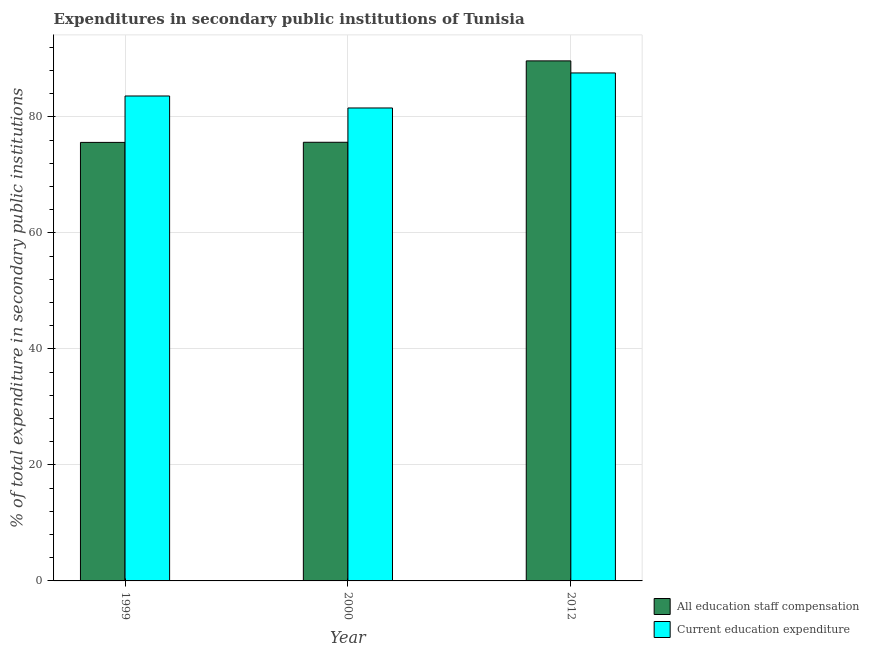How many different coloured bars are there?
Your answer should be compact. 2. Are the number of bars on each tick of the X-axis equal?
Provide a short and direct response. Yes. How many bars are there on the 3rd tick from the left?
Provide a short and direct response. 2. What is the expenditure in staff compensation in 1999?
Make the answer very short. 75.6. Across all years, what is the maximum expenditure in education?
Your answer should be very brief. 87.57. Across all years, what is the minimum expenditure in education?
Your answer should be compact. 81.53. What is the total expenditure in education in the graph?
Keep it short and to the point. 252.71. What is the difference between the expenditure in staff compensation in 1999 and that in 2012?
Provide a short and direct response. -14.05. What is the difference between the expenditure in staff compensation in 2012 and the expenditure in education in 1999?
Keep it short and to the point. 14.05. What is the average expenditure in staff compensation per year?
Provide a short and direct response. 80.29. What is the ratio of the expenditure in staff compensation in 1999 to that in 2012?
Keep it short and to the point. 0.84. Is the expenditure in staff compensation in 1999 less than that in 2012?
Provide a succinct answer. Yes. Is the difference between the expenditure in staff compensation in 2000 and 2012 greater than the difference between the expenditure in education in 2000 and 2012?
Ensure brevity in your answer.  No. What is the difference between the highest and the second highest expenditure in staff compensation?
Keep it short and to the point. 14.03. What is the difference between the highest and the lowest expenditure in education?
Offer a terse response. 6.04. In how many years, is the expenditure in education greater than the average expenditure in education taken over all years?
Make the answer very short. 1. What does the 1st bar from the left in 2000 represents?
Your answer should be compact. All education staff compensation. What does the 1st bar from the right in 2012 represents?
Your answer should be compact. Current education expenditure. How many bars are there?
Offer a terse response. 6. Are all the bars in the graph horizontal?
Give a very brief answer. No. How many years are there in the graph?
Your answer should be very brief. 3. Are the values on the major ticks of Y-axis written in scientific E-notation?
Provide a short and direct response. No. Does the graph contain any zero values?
Your response must be concise. No. Does the graph contain grids?
Your answer should be very brief. Yes. How many legend labels are there?
Provide a succinct answer. 2. How are the legend labels stacked?
Offer a terse response. Vertical. What is the title of the graph?
Your response must be concise. Expenditures in secondary public institutions of Tunisia. Does "Death rate" appear as one of the legend labels in the graph?
Your answer should be compact. No. What is the label or title of the Y-axis?
Offer a terse response. % of total expenditure in secondary public institutions. What is the % of total expenditure in secondary public institutions of All education staff compensation in 1999?
Your answer should be very brief. 75.6. What is the % of total expenditure in secondary public institutions of Current education expenditure in 1999?
Provide a short and direct response. 83.6. What is the % of total expenditure in secondary public institutions in All education staff compensation in 2000?
Your answer should be compact. 75.62. What is the % of total expenditure in secondary public institutions in Current education expenditure in 2000?
Make the answer very short. 81.53. What is the % of total expenditure in secondary public institutions of All education staff compensation in 2012?
Make the answer very short. 89.65. What is the % of total expenditure in secondary public institutions in Current education expenditure in 2012?
Your answer should be very brief. 87.57. Across all years, what is the maximum % of total expenditure in secondary public institutions in All education staff compensation?
Give a very brief answer. 89.65. Across all years, what is the maximum % of total expenditure in secondary public institutions in Current education expenditure?
Keep it short and to the point. 87.57. Across all years, what is the minimum % of total expenditure in secondary public institutions of All education staff compensation?
Offer a terse response. 75.6. Across all years, what is the minimum % of total expenditure in secondary public institutions of Current education expenditure?
Offer a very short reply. 81.53. What is the total % of total expenditure in secondary public institutions of All education staff compensation in the graph?
Make the answer very short. 240.88. What is the total % of total expenditure in secondary public institutions in Current education expenditure in the graph?
Your answer should be compact. 252.71. What is the difference between the % of total expenditure in secondary public institutions in All education staff compensation in 1999 and that in 2000?
Give a very brief answer. -0.02. What is the difference between the % of total expenditure in secondary public institutions of Current education expenditure in 1999 and that in 2000?
Provide a short and direct response. 2.07. What is the difference between the % of total expenditure in secondary public institutions of All education staff compensation in 1999 and that in 2012?
Make the answer very short. -14.05. What is the difference between the % of total expenditure in secondary public institutions of Current education expenditure in 1999 and that in 2012?
Offer a very short reply. -3.97. What is the difference between the % of total expenditure in secondary public institutions of All education staff compensation in 2000 and that in 2012?
Offer a very short reply. -14.03. What is the difference between the % of total expenditure in secondary public institutions in Current education expenditure in 2000 and that in 2012?
Your response must be concise. -6.04. What is the difference between the % of total expenditure in secondary public institutions of All education staff compensation in 1999 and the % of total expenditure in secondary public institutions of Current education expenditure in 2000?
Your answer should be very brief. -5.93. What is the difference between the % of total expenditure in secondary public institutions in All education staff compensation in 1999 and the % of total expenditure in secondary public institutions in Current education expenditure in 2012?
Ensure brevity in your answer.  -11.97. What is the difference between the % of total expenditure in secondary public institutions in All education staff compensation in 2000 and the % of total expenditure in secondary public institutions in Current education expenditure in 2012?
Provide a short and direct response. -11.95. What is the average % of total expenditure in secondary public institutions in All education staff compensation per year?
Your answer should be compact. 80.29. What is the average % of total expenditure in secondary public institutions of Current education expenditure per year?
Provide a short and direct response. 84.24. In the year 1999, what is the difference between the % of total expenditure in secondary public institutions in All education staff compensation and % of total expenditure in secondary public institutions in Current education expenditure?
Provide a succinct answer. -8. In the year 2000, what is the difference between the % of total expenditure in secondary public institutions in All education staff compensation and % of total expenditure in secondary public institutions in Current education expenditure?
Give a very brief answer. -5.91. In the year 2012, what is the difference between the % of total expenditure in secondary public institutions of All education staff compensation and % of total expenditure in secondary public institutions of Current education expenditure?
Keep it short and to the point. 2.08. What is the ratio of the % of total expenditure in secondary public institutions in All education staff compensation in 1999 to that in 2000?
Give a very brief answer. 1. What is the ratio of the % of total expenditure in secondary public institutions in Current education expenditure in 1999 to that in 2000?
Provide a succinct answer. 1.03. What is the ratio of the % of total expenditure in secondary public institutions of All education staff compensation in 1999 to that in 2012?
Your answer should be compact. 0.84. What is the ratio of the % of total expenditure in secondary public institutions in Current education expenditure in 1999 to that in 2012?
Provide a short and direct response. 0.95. What is the ratio of the % of total expenditure in secondary public institutions of All education staff compensation in 2000 to that in 2012?
Keep it short and to the point. 0.84. What is the ratio of the % of total expenditure in secondary public institutions in Current education expenditure in 2000 to that in 2012?
Ensure brevity in your answer.  0.93. What is the difference between the highest and the second highest % of total expenditure in secondary public institutions of All education staff compensation?
Offer a very short reply. 14.03. What is the difference between the highest and the second highest % of total expenditure in secondary public institutions in Current education expenditure?
Make the answer very short. 3.97. What is the difference between the highest and the lowest % of total expenditure in secondary public institutions of All education staff compensation?
Offer a terse response. 14.05. What is the difference between the highest and the lowest % of total expenditure in secondary public institutions of Current education expenditure?
Ensure brevity in your answer.  6.04. 